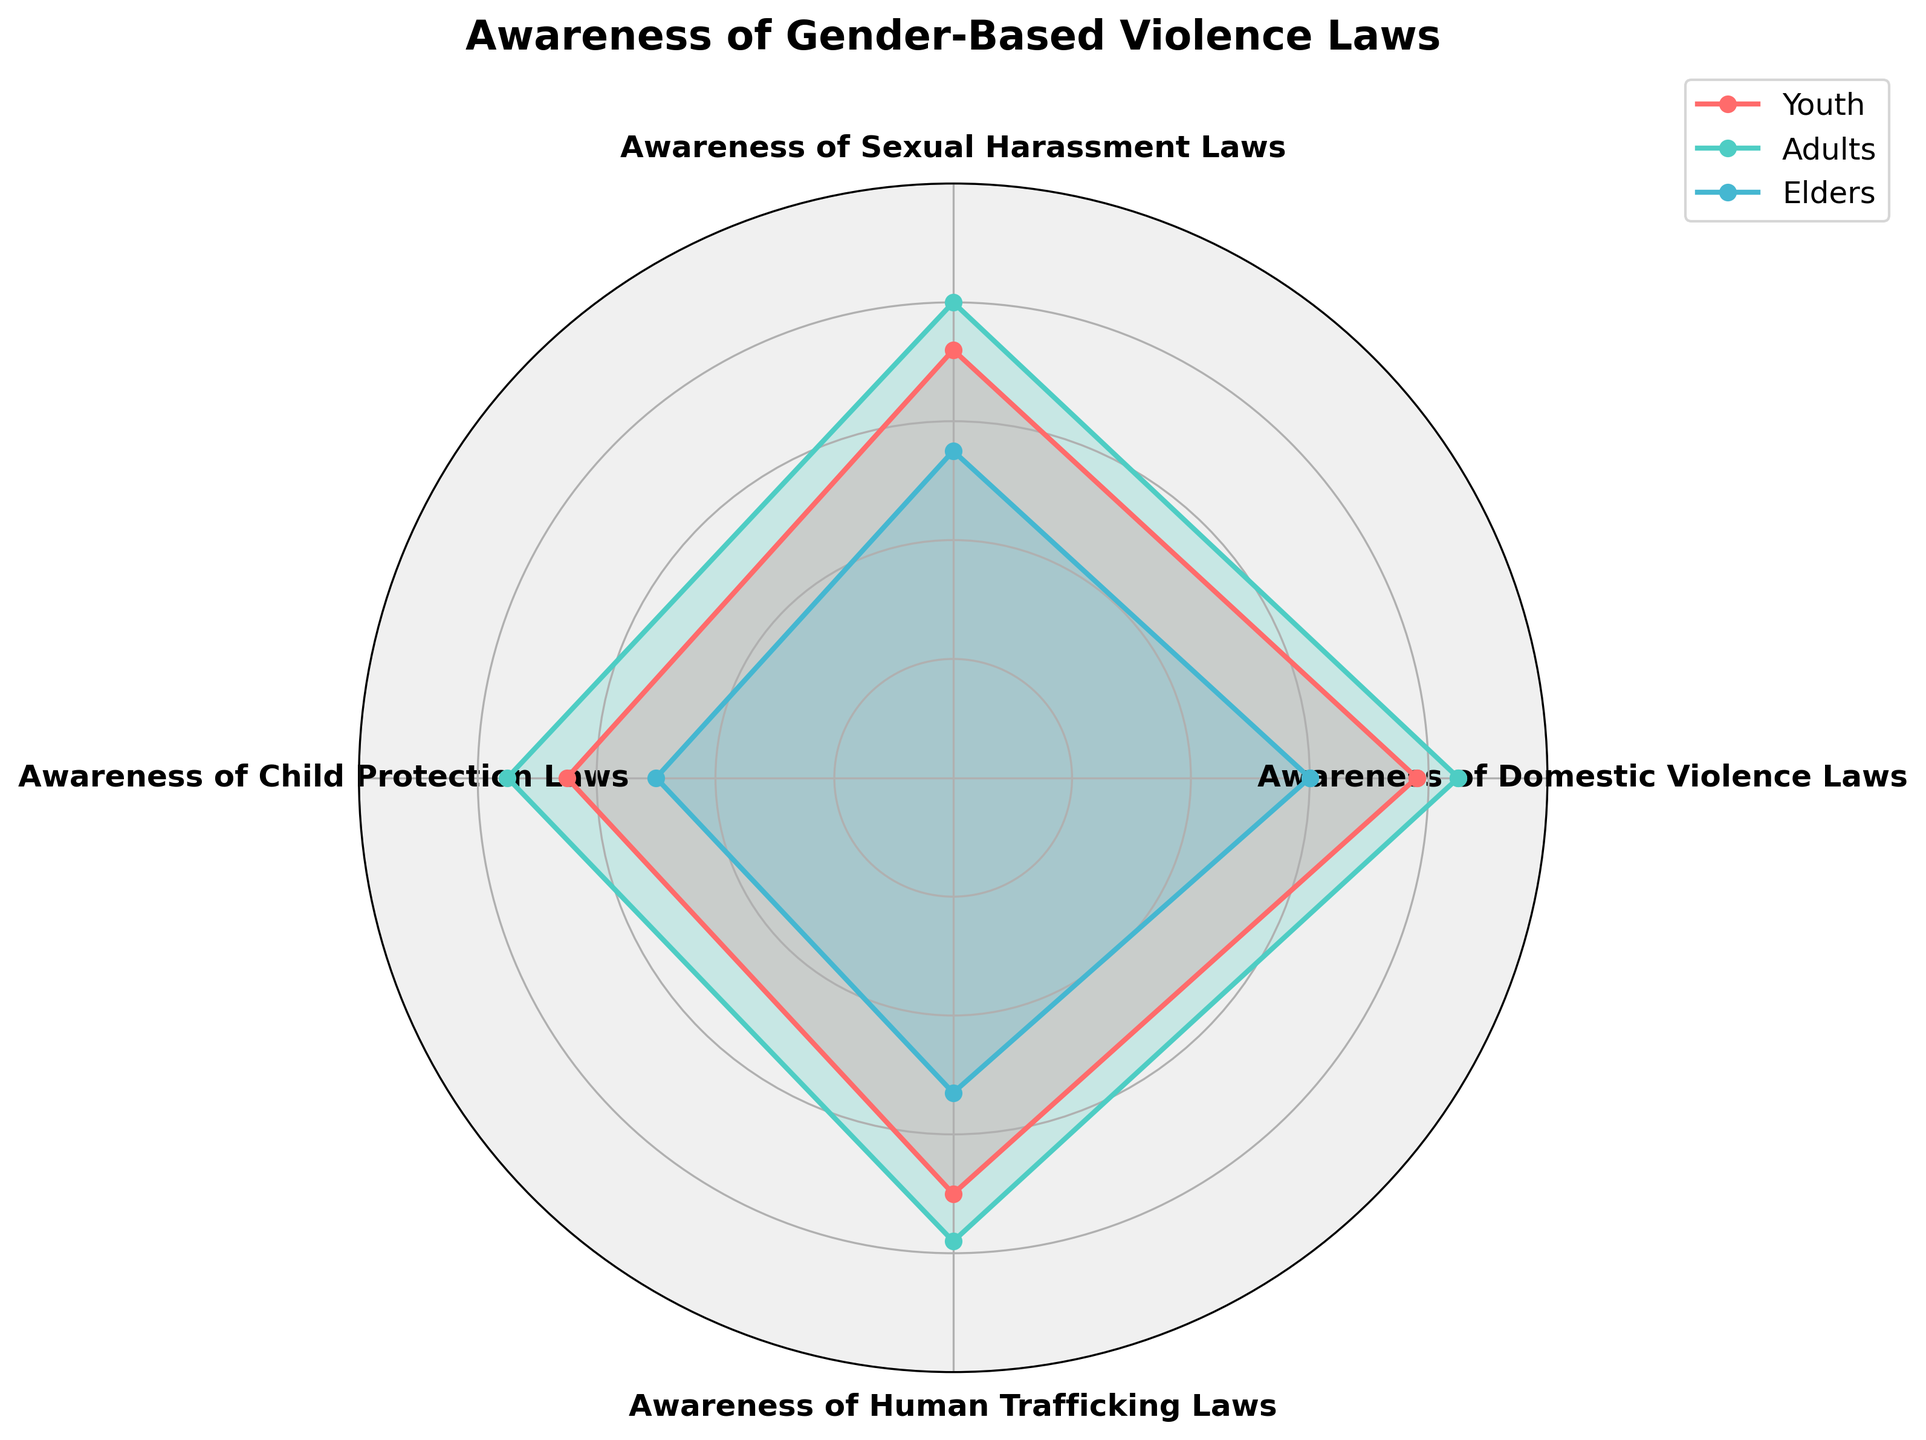What is the highest awareness level among Youth for any law category? The radar chart shows that Youth have the highest awareness level of Domestic Violence Laws at 78.
Answer: 78 Which group has the lowest awareness level across all law categories? By visual inspection of the radar chart, Elders have the lowest awareness level in every law category.
Answer: Elders How does awareness of Human Trafficking Laws differ between Adults and Elders? The radar chart indicates that Adults have an awareness level of 78 for Human Trafficking Laws, while Elders have a level of 53. The difference is 78 - 53 = 25.
Answer: 25 Which law category shows the smallest difference in awareness levels between Youth and Adults? For each category: Domestic Violence Laws (85-78=7), Sexual Harassment Laws (80-72=8), Child Protection Laws (75-65=10), and Human Trafficking Laws (78-70=8). The smallest difference is in Domestic Violence Laws with a value of 7.
Answer: Domestic Violence Laws What is the average awareness level of Child Protection Laws among the three groups? The awareness levels are Youth (65), Adults (75), and Elders (50). The average is (65 + 75 + 50) / 3 = 63.33.
Answer: 63.33 Which group has the highest overall awareness of gender-based violence laws? The radar chart shows that Adults have the highest points in each category except Domestic Violence Laws where Youth have 78 and Elders have the lowest overall.
Answer: Adults For which law category do Elders have the highest awareness level? The awareness level of Elders for different categories are: Domestic Violence Laws (60), Sexual Harassment Laws (55), Child Protection Laws (50), and Human Trafficking Laws (53). Domestic Violence Laws is 60.
Answer: Domestic Violence Laws Compare the awareness of Sexual Harassment Laws between Youth and Adults, which one is greater and by how much? The radar chart shows the awareness levels: Youth (72) and Adults (80). The difference is 80 - 72 = 8.
Answer: Adults by 8 What is the range of awareness levels for Domestic Violence Laws among the three groups? Awareness levels for Domestic Violence Laws: Youth (78), Adults (85), and Elders (60). Range is 85 - 60 = 25.
Answer: 25 Which groups have equal awareness levels for Child Protection Laws and Human Trafficking Laws? The given awareness levels: Child Protection Laws (Youth: 65, Adults: 75, Elders: 50) and Human Trafficking Laws (Youth: 70, Adults: 78, Elders: 53). No groups have equal awareness levels for both categories.
Answer: None 